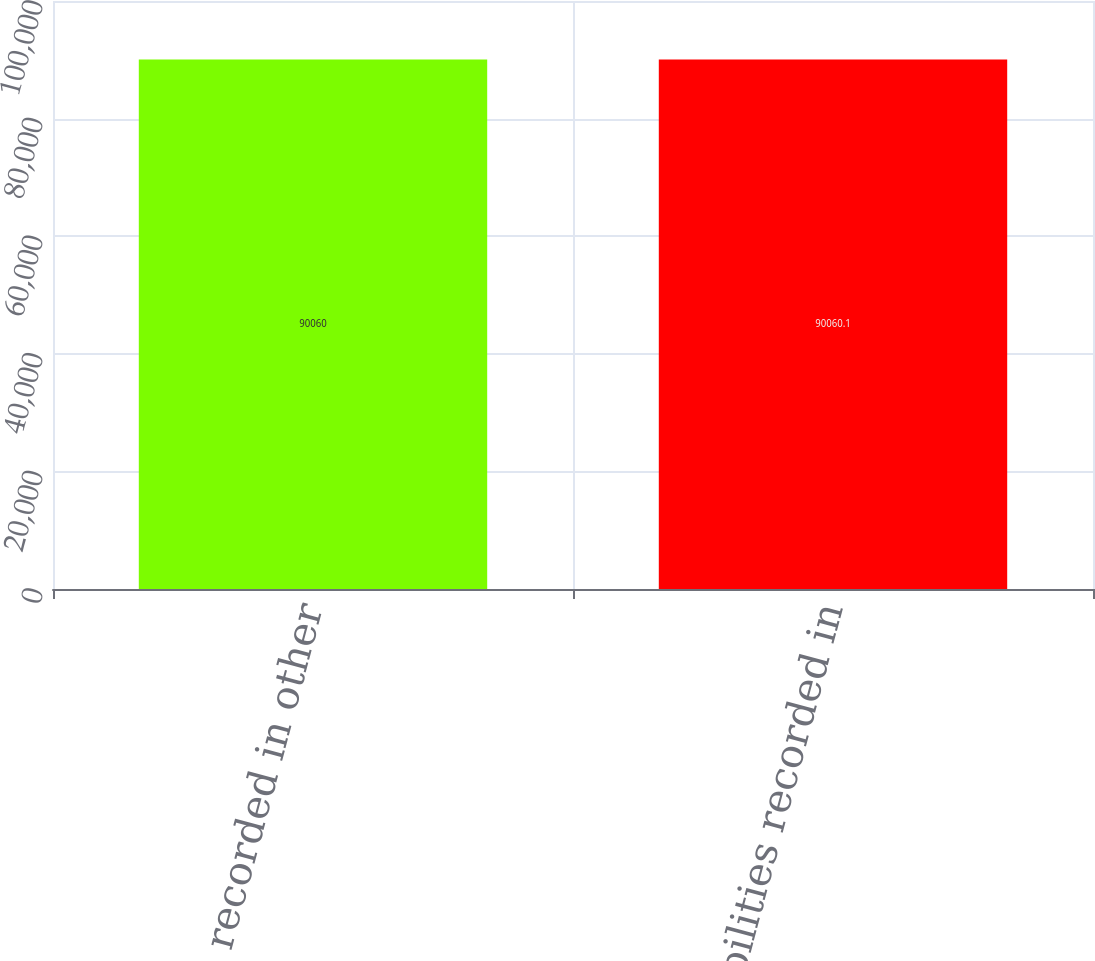Convert chart. <chart><loc_0><loc_0><loc_500><loc_500><bar_chart><fcel>Plan assets recorded in other<fcel>Plan liabilities recorded in<nl><fcel>90060<fcel>90060.1<nl></chart> 